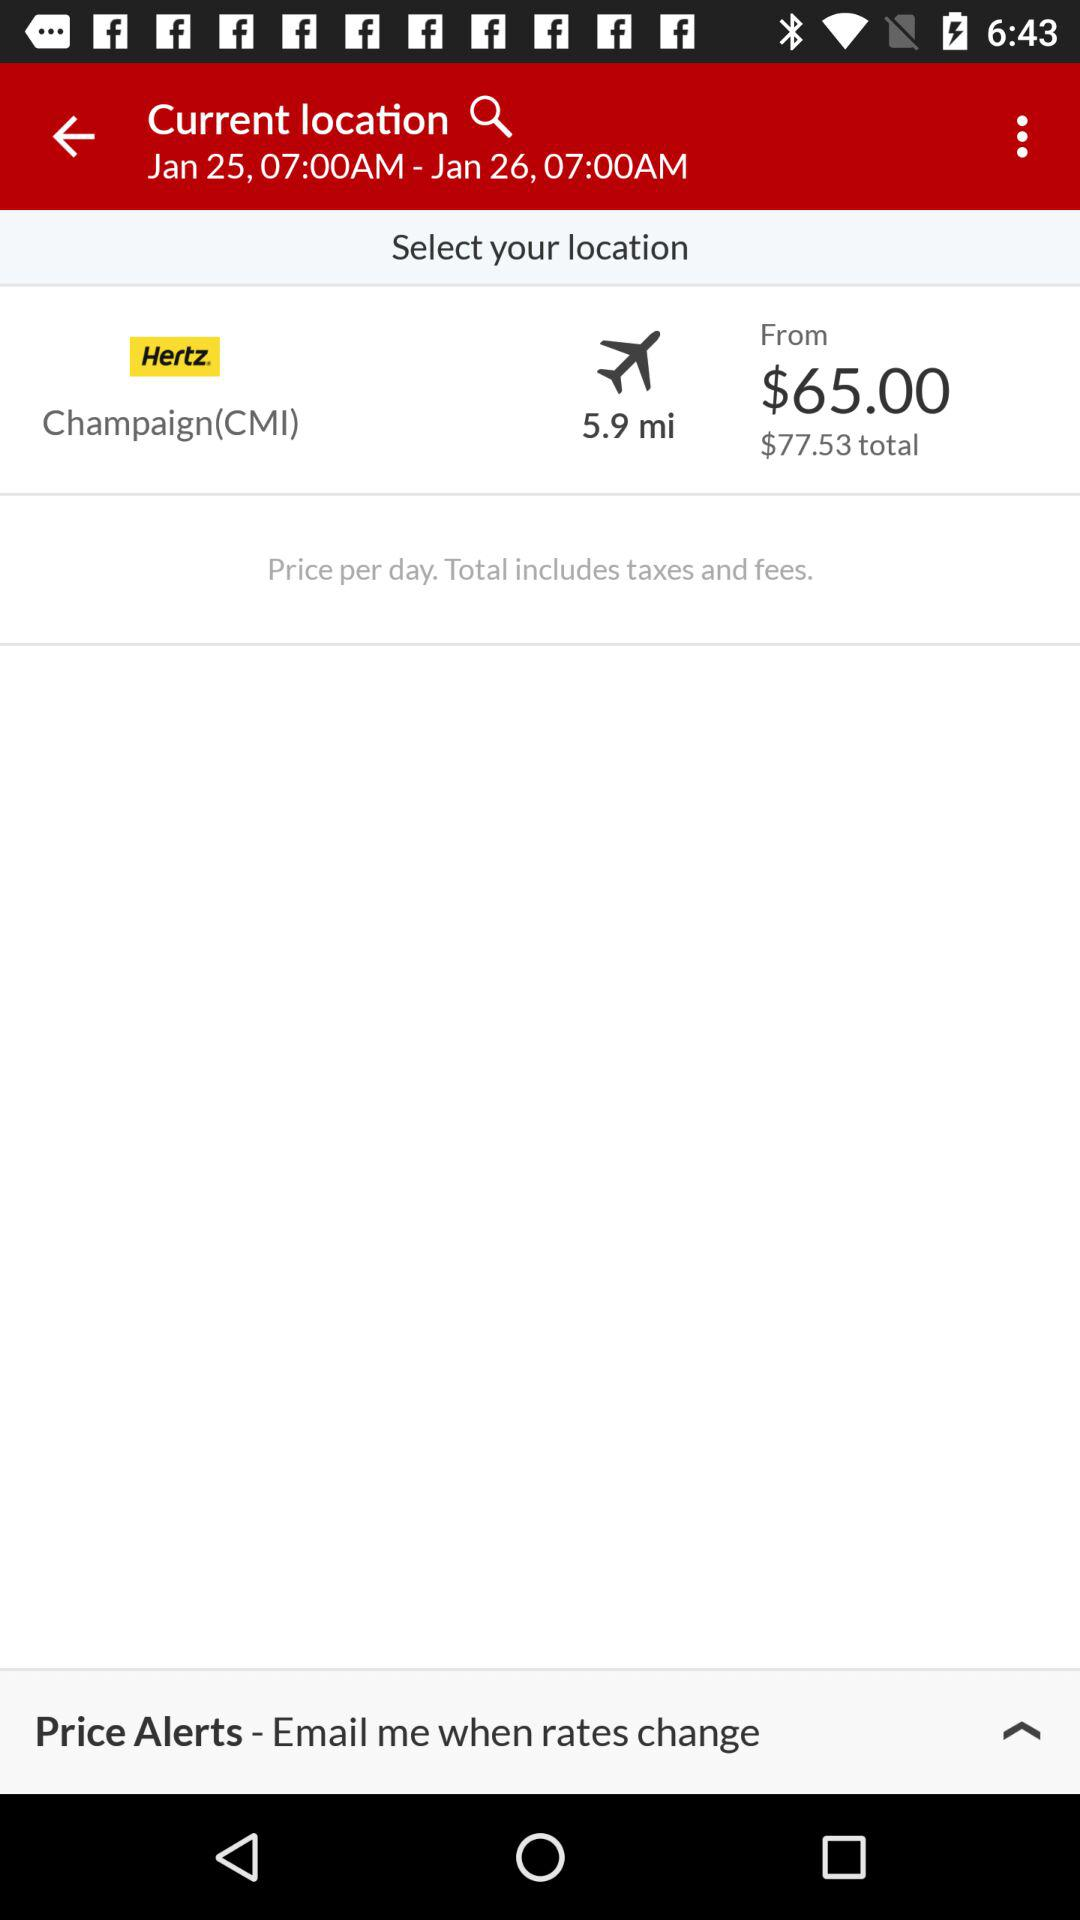What is the distance? The distance is 5.9 miles. 